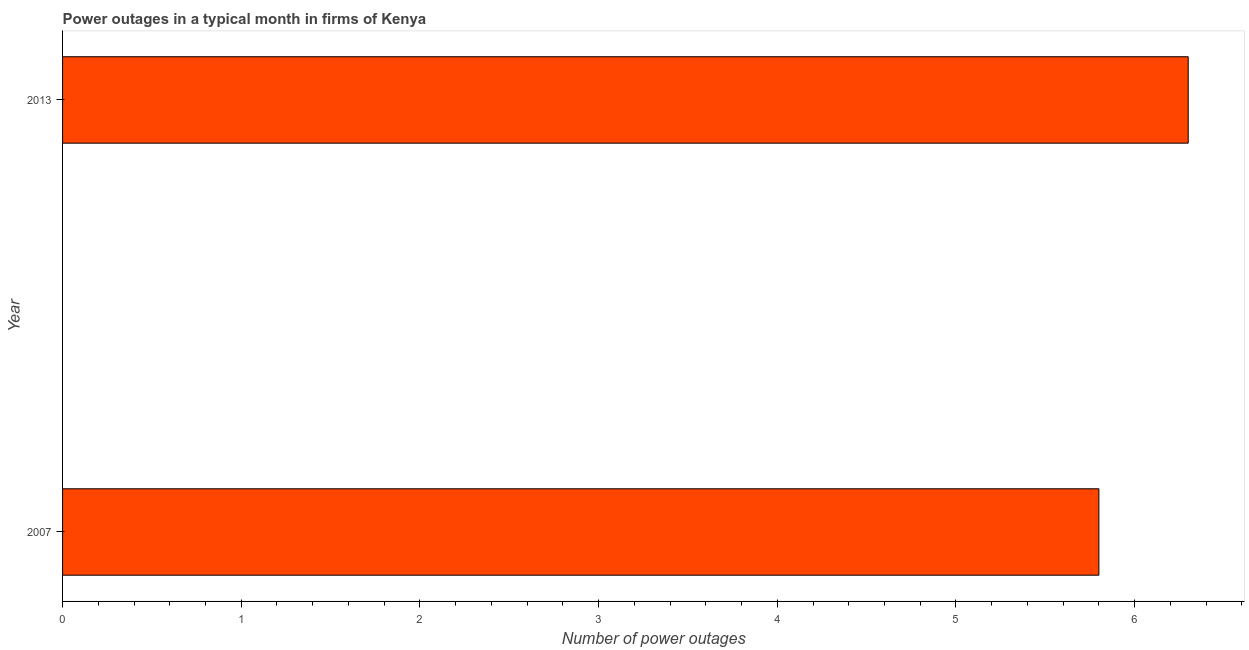Does the graph contain grids?
Your answer should be very brief. No. What is the title of the graph?
Ensure brevity in your answer.  Power outages in a typical month in firms of Kenya. What is the label or title of the X-axis?
Give a very brief answer. Number of power outages. Across all years, what is the maximum number of power outages?
Make the answer very short. 6.3. Across all years, what is the minimum number of power outages?
Your answer should be very brief. 5.8. In which year was the number of power outages minimum?
Make the answer very short. 2007. What is the average number of power outages per year?
Keep it short and to the point. 6.05. What is the median number of power outages?
Your answer should be very brief. 6.05. Do a majority of the years between 2007 and 2013 (inclusive) have number of power outages greater than 0.2 ?
Offer a very short reply. Yes. What is the ratio of the number of power outages in 2007 to that in 2013?
Keep it short and to the point. 0.92. In how many years, is the number of power outages greater than the average number of power outages taken over all years?
Keep it short and to the point. 1. How many bars are there?
Give a very brief answer. 2. What is the difference between two consecutive major ticks on the X-axis?
Make the answer very short. 1. What is the ratio of the Number of power outages in 2007 to that in 2013?
Give a very brief answer. 0.92. 